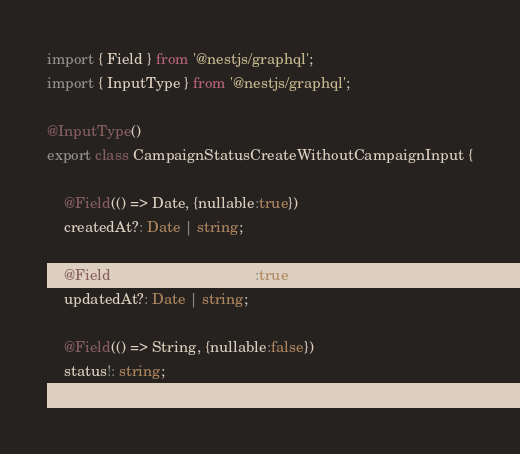Convert code to text. <code><loc_0><loc_0><loc_500><loc_500><_TypeScript_>import { Field } from '@nestjs/graphql';
import { InputType } from '@nestjs/graphql';

@InputType()
export class CampaignStatusCreateWithoutCampaignInput {

    @Field(() => Date, {nullable:true})
    createdAt?: Date | string;

    @Field(() => Date, {nullable:true})
    updatedAt?: Date | string;

    @Field(() => String, {nullable:false})
    status!: string;
}
</code> 